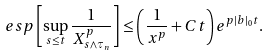Convert formula to latex. <formula><loc_0><loc_0><loc_500><loc_500>\ e s p \left [ \sup _ { s \leq t } \frac { 1 } { X _ { s \wedge \tau _ { n } } ^ { p } } \right ] \leq \left ( \frac { 1 } { x ^ { p } } + C t \right ) e ^ { p | b | _ { 0 } t } .</formula> 